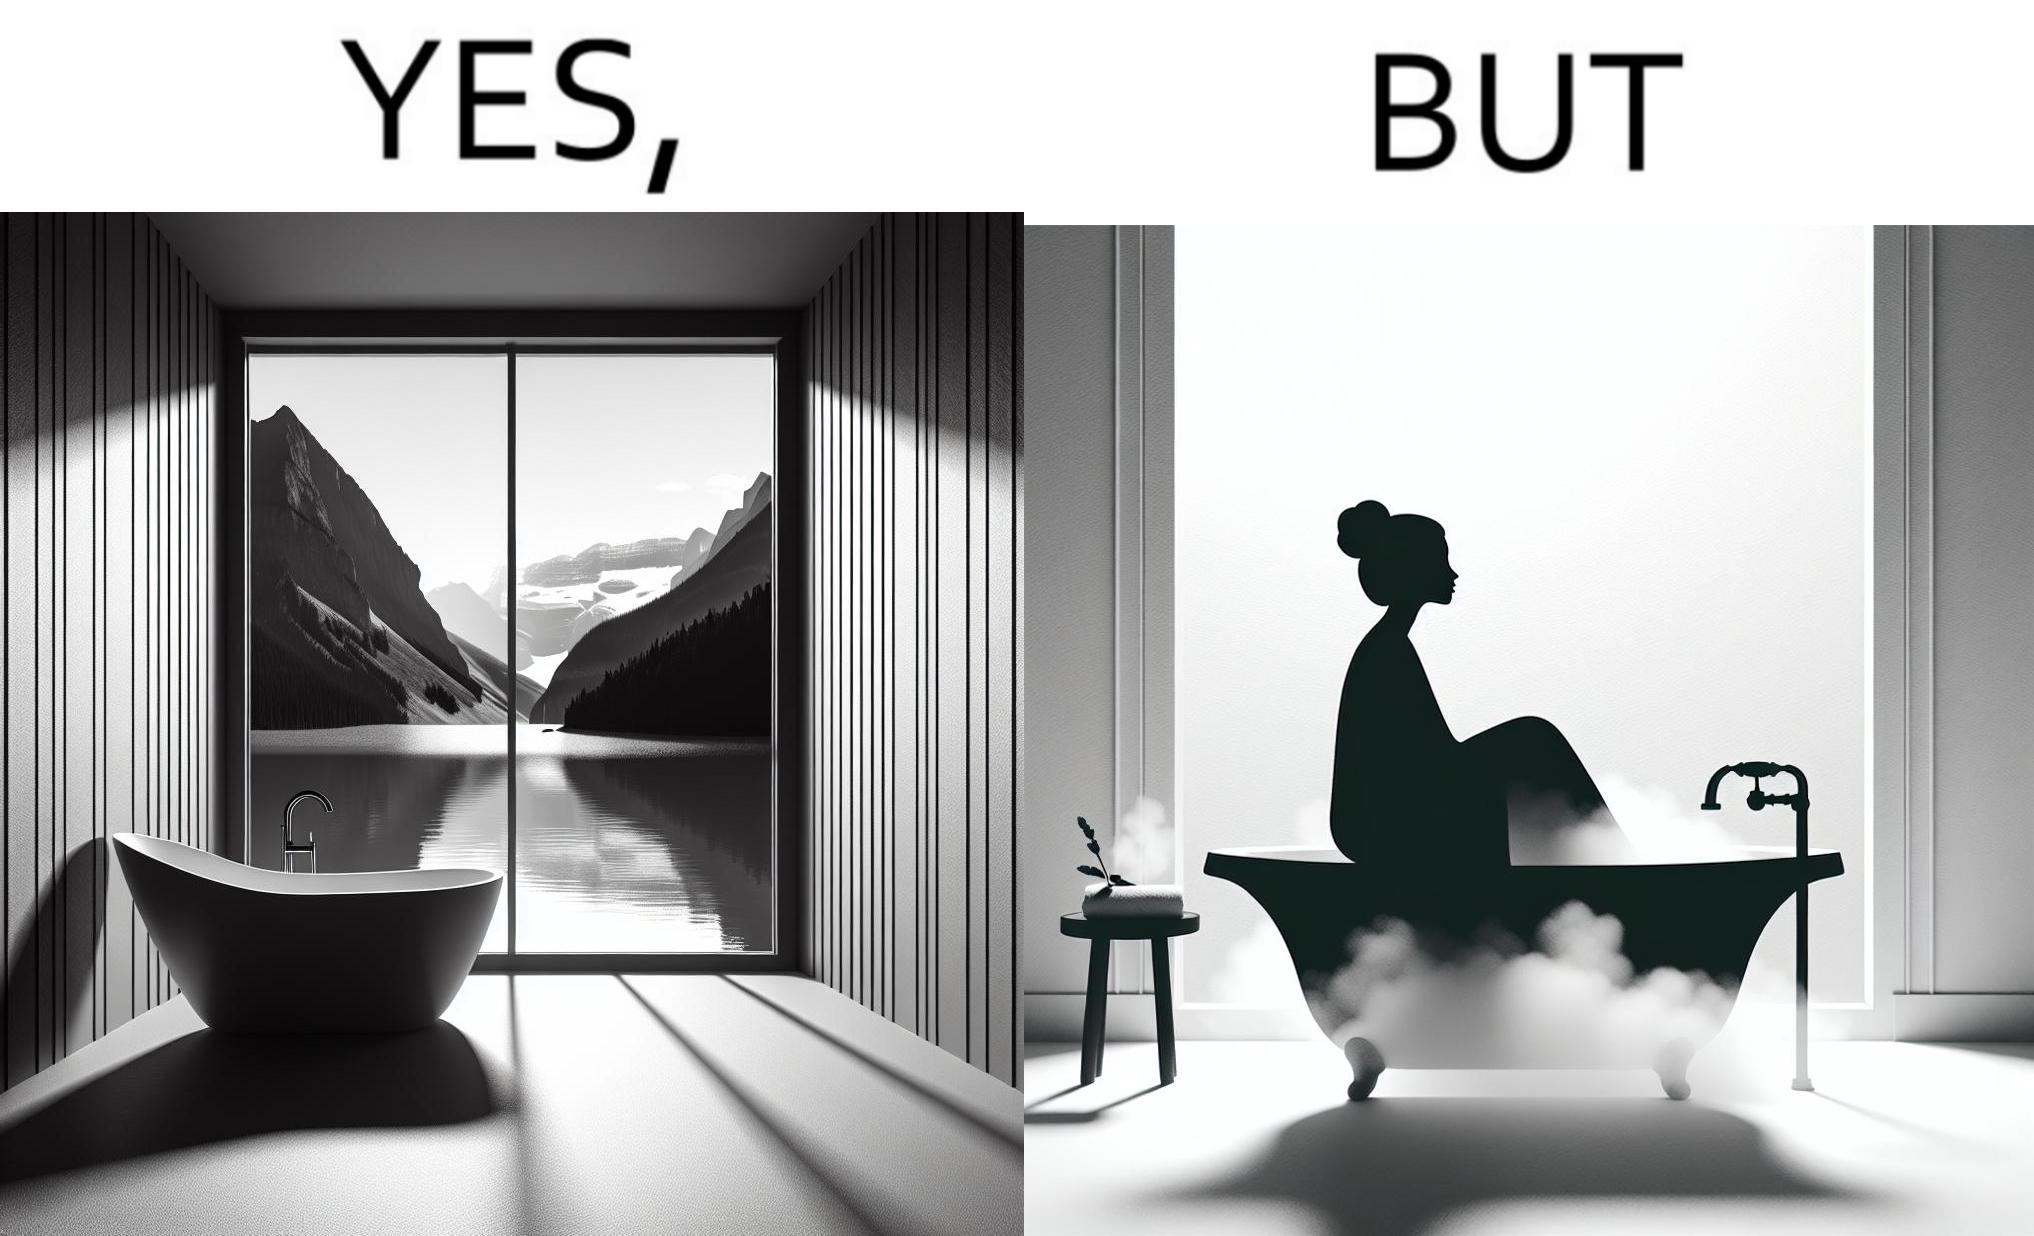Describe the content of this image. The image is ironical, as a bathtub near a window having a very scenic view, becomes misty when someone is bathing, thus making the scenic view blurry. 